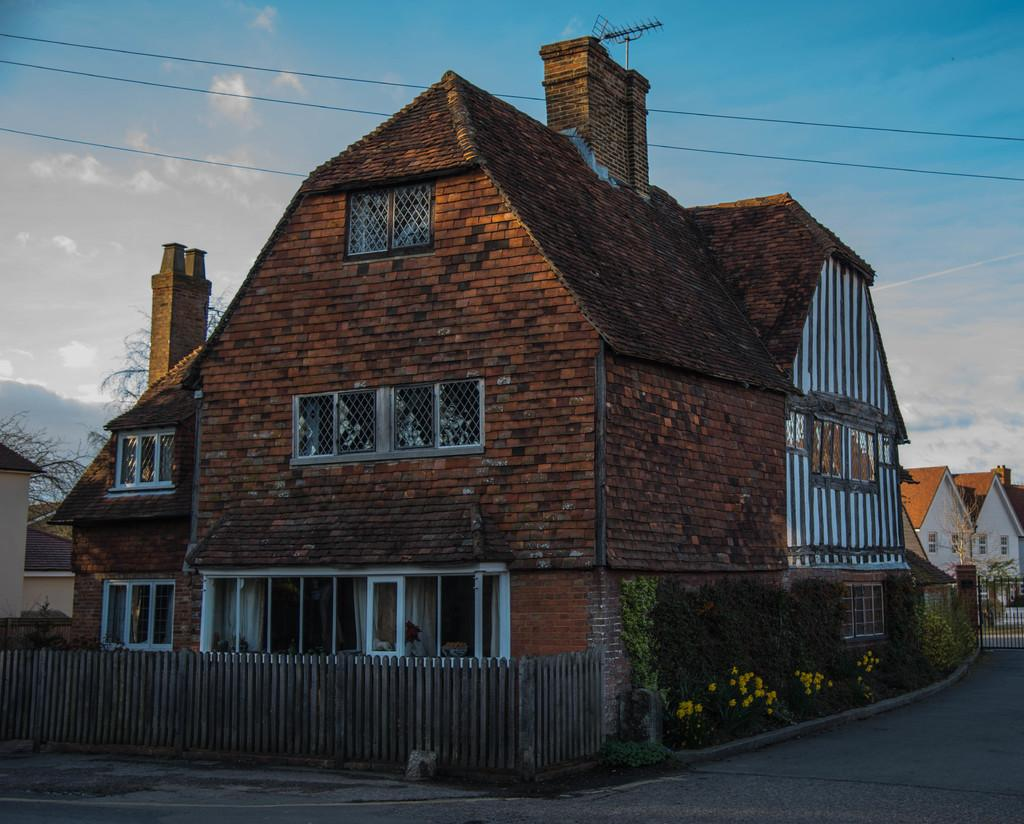What type of barrier can be seen in the image? There is a fence in the image. What kind of vegetation is present in the image? There are plants with flowers and trees in the image. What type of structures are visible in the image? There are houses in the image. What can be seen in the background of the image? The sky is visible in the background of the image. How many snakes are climbing on the fence in the image? There are no snakes present in the image. What type of nut is being used to decorate the plants in the image? There are no nuts used for decoration in the image; the plants have flowers. 